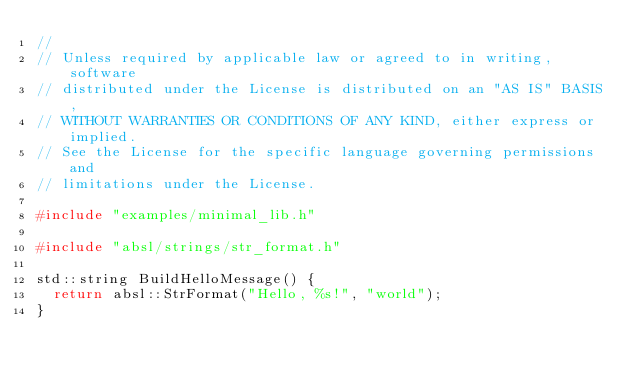Convert code to text. <code><loc_0><loc_0><loc_500><loc_500><_C++_>//
// Unless required by applicable law or agreed to in writing, software
// distributed under the License is distributed on an "AS IS" BASIS,
// WITHOUT WARRANTIES OR CONDITIONS OF ANY KIND, either express or implied.
// See the License for the specific language governing permissions and
// limitations under the License.

#include "examples/minimal_lib.h"

#include "absl/strings/str_format.h"

std::string BuildHelloMessage() {
  return absl::StrFormat("Hello, %s!", "world");
}
</code> 